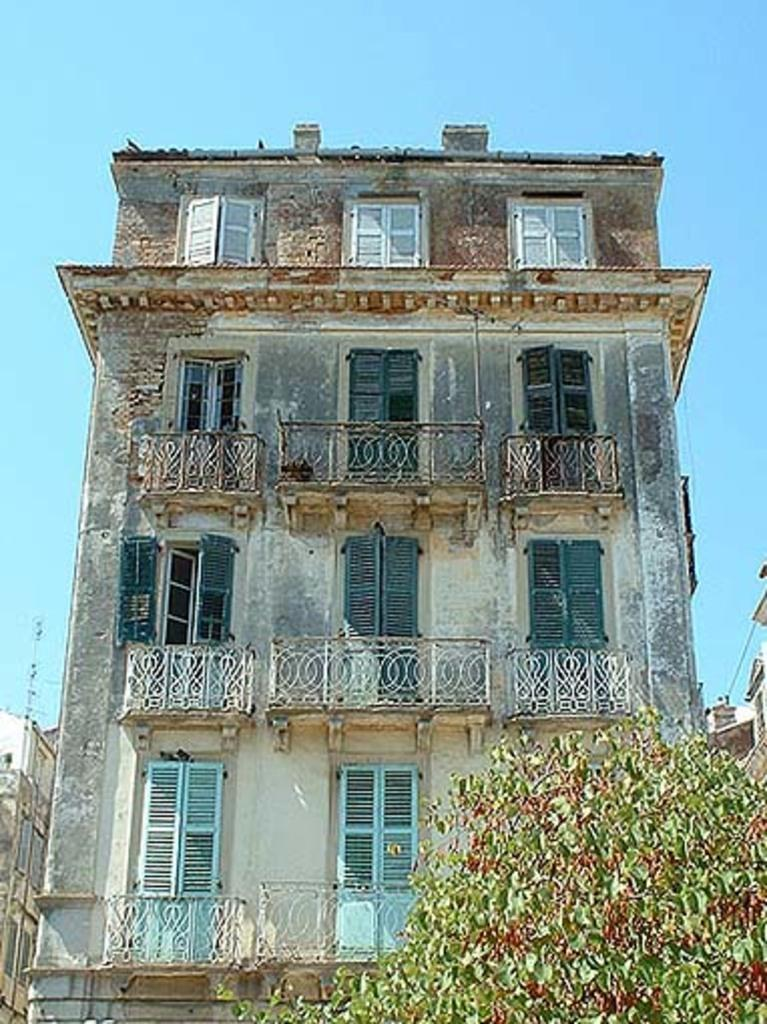What type of living organisms can be seen in the image? Plants can be seen in the image. What can be seen in the background of the image? There are buildings and glass windows in the background of the image. What is the color of the sky in the image? The sky is blue in color. Can you see a cat swimming in the goldfish bowl on the wall in the image? There is no cat or goldfish bowl on the wall in the image. 